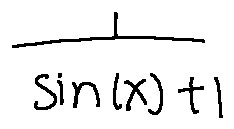<formula> <loc_0><loc_0><loc_500><loc_500>\frac { 1 } { \sin ( x ) + 1 }</formula> 